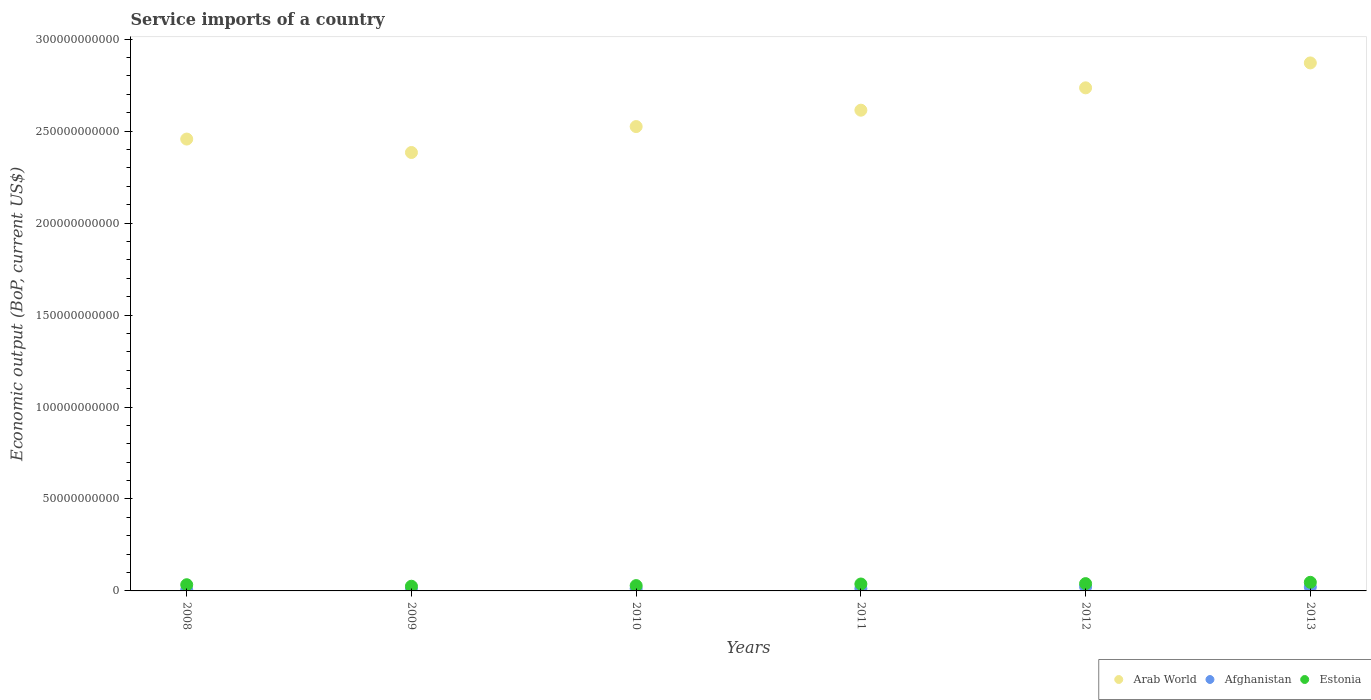How many different coloured dotlines are there?
Provide a short and direct response. 3. Is the number of dotlines equal to the number of legend labels?
Offer a terse response. Yes. What is the service imports in Afghanistan in 2010?
Make the answer very short. 1.26e+09. Across all years, what is the maximum service imports in Arab World?
Provide a short and direct response. 2.87e+11. Across all years, what is the minimum service imports in Afghanistan?
Make the answer very short. 5.71e+08. In which year was the service imports in Estonia minimum?
Ensure brevity in your answer.  2009. What is the total service imports in Estonia in the graph?
Offer a terse response. 2.12e+1. What is the difference between the service imports in Estonia in 2008 and that in 2009?
Your response must be concise. 8.25e+08. What is the difference between the service imports in Arab World in 2013 and the service imports in Estonia in 2009?
Provide a succinct answer. 2.85e+11. What is the average service imports in Afghanistan per year?
Provide a short and direct response. 1.39e+09. In the year 2010, what is the difference between the service imports in Arab World and service imports in Estonia?
Offer a terse response. 2.50e+11. In how many years, is the service imports in Arab World greater than 210000000000 US$?
Keep it short and to the point. 6. What is the ratio of the service imports in Estonia in 2008 to that in 2010?
Keep it short and to the point. 1.16. Is the service imports in Estonia in 2009 less than that in 2010?
Provide a short and direct response. Yes. What is the difference between the highest and the second highest service imports in Estonia?
Keep it short and to the point. 7.12e+08. What is the difference between the highest and the lowest service imports in Afghanistan?
Ensure brevity in your answer.  1.67e+09. In how many years, is the service imports in Estonia greater than the average service imports in Estonia taken over all years?
Your answer should be compact. 3. Is the sum of the service imports in Arab World in 2012 and 2013 greater than the maximum service imports in Estonia across all years?
Keep it short and to the point. Yes. Is it the case that in every year, the sum of the service imports in Arab World and service imports in Afghanistan  is greater than the service imports in Estonia?
Give a very brief answer. Yes. Does the service imports in Estonia monotonically increase over the years?
Make the answer very short. No. How many years are there in the graph?
Provide a short and direct response. 6. Does the graph contain any zero values?
Your answer should be compact. No. Does the graph contain grids?
Offer a terse response. No. What is the title of the graph?
Offer a terse response. Service imports of a country. What is the label or title of the Y-axis?
Offer a very short reply. Economic output (BoP, current US$). What is the Economic output (BoP, current US$) of Arab World in 2008?
Ensure brevity in your answer.  2.46e+11. What is the Economic output (BoP, current US$) in Afghanistan in 2008?
Your answer should be compact. 5.71e+08. What is the Economic output (BoP, current US$) in Estonia in 2008?
Your answer should be very brief. 3.37e+09. What is the Economic output (BoP, current US$) in Arab World in 2009?
Keep it short and to the point. 2.38e+11. What is the Economic output (BoP, current US$) in Afghanistan in 2009?
Give a very brief answer. 8.36e+08. What is the Economic output (BoP, current US$) of Estonia in 2009?
Provide a succinct answer. 2.54e+09. What is the Economic output (BoP, current US$) of Arab World in 2010?
Your answer should be very brief. 2.52e+11. What is the Economic output (BoP, current US$) in Afghanistan in 2010?
Keep it short and to the point. 1.26e+09. What is the Economic output (BoP, current US$) of Estonia in 2010?
Offer a terse response. 2.89e+09. What is the Economic output (BoP, current US$) in Arab World in 2011?
Offer a very short reply. 2.61e+11. What is the Economic output (BoP, current US$) in Afghanistan in 2011?
Keep it short and to the point. 1.29e+09. What is the Economic output (BoP, current US$) in Estonia in 2011?
Your response must be concise. 3.76e+09. What is the Economic output (BoP, current US$) of Arab World in 2012?
Your answer should be very brief. 2.74e+11. What is the Economic output (BoP, current US$) in Afghanistan in 2012?
Provide a short and direct response. 2.24e+09. What is the Economic output (BoP, current US$) in Estonia in 2012?
Provide a succinct answer. 3.96e+09. What is the Economic output (BoP, current US$) of Arab World in 2013?
Provide a succinct answer. 2.87e+11. What is the Economic output (BoP, current US$) of Afghanistan in 2013?
Provide a succinct answer. 2.11e+09. What is the Economic output (BoP, current US$) in Estonia in 2013?
Provide a succinct answer. 4.68e+09. Across all years, what is the maximum Economic output (BoP, current US$) of Arab World?
Keep it short and to the point. 2.87e+11. Across all years, what is the maximum Economic output (BoP, current US$) of Afghanistan?
Offer a very short reply. 2.24e+09. Across all years, what is the maximum Economic output (BoP, current US$) in Estonia?
Your response must be concise. 4.68e+09. Across all years, what is the minimum Economic output (BoP, current US$) of Arab World?
Keep it short and to the point. 2.38e+11. Across all years, what is the minimum Economic output (BoP, current US$) in Afghanistan?
Offer a very short reply. 5.71e+08. Across all years, what is the minimum Economic output (BoP, current US$) of Estonia?
Your answer should be compact. 2.54e+09. What is the total Economic output (BoP, current US$) in Arab World in the graph?
Ensure brevity in your answer.  1.56e+12. What is the total Economic output (BoP, current US$) in Afghanistan in the graph?
Your answer should be compact. 8.32e+09. What is the total Economic output (BoP, current US$) in Estonia in the graph?
Offer a terse response. 2.12e+1. What is the difference between the Economic output (BoP, current US$) of Arab World in 2008 and that in 2009?
Provide a short and direct response. 7.30e+09. What is the difference between the Economic output (BoP, current US$) of Afghanistan in 2008 and that in 2009?
Your response must be concise. -2.65e+08. What is the difference between the Economic output (BoP, current US$) in Estonia in 2008 and that in 2009?
Your response must be concise. 8.25e+08. What is the difference between the Economic output (BoP, current US$) in Arab World in 2008 and that in 2010?
Your answer should be very brief. -6.80e+09. What is the difference between the Economic output (BoP, current US$) in Afghanistan in 2008 and that in 2010?
Provide a short and direct response. -6.88e+08. What is the difference between the Economic output (BoP, current US$) in Estonia in 2008 and that in 2010?
Offer a very short reply. 4.76e+08. What is the difference between the Economic output (BoP, current US$) in Arab World in 2008 and that in 2011?
Offer a terse response. -1.57e+1. What is the difference between the Economic output (BoP, current US$) of Afghanistan in 2008 and that in 2011?
Your answer should be compact. -7.18e+08. What is the difference between the Economic output (BoP, current US$) in Estonia in 2008 and that in 2011?
Your answer should be compact. -3.96e+08. What is the difference between the Economic output (BoP, current US$) of Arab World in 2008 and that in 2012?
Make the answer very short. -2.79e+1. What is the difference between the Economic output (BoP, current US$) in Afghanistan in 2008 and that in 2012?
Your response must be concise. -1.67e+09. What is the difference between the Economic output (BoP, current US$) of Estonia in 2008 and that in 2012?
Provide a succinct answer. -5.98e+08. What is the difference between the Economic output (BoP, current US$) in Arab World in 2008 and that in 2013?
Make the answer very short. -4.14e+1. What is the difference between the Economic output (BoP, current US$) of Afghanistan in 2008 and that in 2013?
Give a very brief answer. -1.54e+09. What is the difference between the Economic output (BoP, current US$) of Estonia in 2008 and that in 2013?
Your answer should be very brief. -1.31e+09. What is the difference between the Economic output (BoP, current US$) in Arab World in 2009 and that in 2010?
Your answer should be very brief. -1.41e+1. What is the difference between the Economic output (BoP, current US$) of Afghanistan in 2009 and that in 2010?
Ensure brevity in your answer.  -4.23e+08. What is the difference between the Economic output (BoP, current US$) of Estonia in 2009 and that in 2010?
Give a very brief answer. -3.49e+08. What is the difference between the Economic output (BoP, current US$) in Arab World in 2009 and that in 2011?
Give a very brief answer. -2.30e+1. What is the difference between the Economic output (BoP, current US$) of Afghanistan in 2009 and that in 2011?
Your answer should be compact. -4.54e+08. What is the difference between the Economic output (BoP, current US$) of Estonia in 2009 and that in 2011?
Provide a succinct answer. -1.22e+09. What is the difference between the Economic output (BoP, current US$) in Arab World in 2009 and that in 2012?
Offer a terse response. -3.52e+1. What is the difference between the Economic output (BoP, current US$) in Afghanistan in 2009 and that in 2012?
Your answer should be compact. -1.41e+09. What is the difference between the Economic output (BoP, current US$) of Estonia in 2009 and that in 2012?
Your response must be concise. -1.42e+09. What is the difference between the Economic output (BoP, current US$) in Arab World in 2009 and that in 2013?
Keep it short and to the point. -4.87e+1. What is the difference between the Economic output (BoP, current US$) in Afghanistan in 2009 and that in 2013?
Your answer should be compact. -1.28e+09. What is the difference between the Economic output (BoP, current US$) of Estonia in 2009 and that in 2013?
Your response must be concise. -2.14e+09. What is the difference between the Economic output (BoP, current US$) of Arab World in 2010 and that in 2011?
Make the answer very short. -8.90e+09. What is the difference between the Economic output (BoP, current US$) in Afghanistan in 2010 and that in 2011?
Offer a terse response. -3.05e+07. What is the difference between the Economic output (BoP, current US$) of Estonia in 2010 and that in 2011?
Offer a terse response. -8.72e+08. What is the difference between the Economic output (BoP, current US$) of Arab World in 2010 and that in 2012?
Provide a short and direct response. -2.11e+1. What is the difference between the Economic output (BoP, current US$) in Afghanistan in 2010 and that in 2012?
Provide a succinct answer. -9.86e+08. What is the difference between the Economic output (BoP, current US$) of Estonia in 2010 and that in 2012?
Give a very brief answer. -1.07e+09. What is the difference between the Economic output (BoP, current US$) of Arab World in 2010 and that in 2013?
Offer a very short reply. -3.46e+1. What is the difference between the Economic output (BoP, current US$) of Afghanistan in 2010 and that in 2013?
Ensure brevity in your answer.  -8.56e+08. What is the difference between the Economic output (BoP, current US$) in Estonia in 2010 and that in 2013?
Provide a short and direct response. -1.79e+09. What is the difference between the Economic output (BoP, current US$) in Arab World in 2011 and that in 2012?
Keep it short and to the point. -1.22e+1. What is the difference between the Economic output (BoP, current US$) of Afghanistan in 2011 and that in 2012?
Offer a very short reply. -9.55e+08. What is the difference between the Economic output (BoP, current US$) in Estonia in 2011 and that in 2012?
Your response must be concise. -2.02e+08. What is the difference between the Economic output (BoP, current US$) of Arab World in 2011 and that in 2013?
Provide a short and direct response. -2.57e+1. What is the difference between the Economic output (BoP, current US$) of Afghanistan in 2011 and that in 2013?
Your response must be concise. -8.25e+08. What is the difference between the Economic output (BoP, current US$) in Estonia in 2011 and that in 2013?
Keep it short and to the point. -9.14e+08. What is the difference between the Economic output (BoP, current US$) in Arab World in 2012 and that in 2013?
Your answer should be compact. -1.35e+1. What is the difference between the Economic output (BoP, current US$) of Afghanistan in 2012 and that in 2013?
Provide a succinct answer. 1.30e+08. What is the difference between the Economic output (BoP, current US$) in Estonia in 2012 and that in 2013?
Keep it short and to the point. -7.12e+08. What is the difference between the Economic output (BoP, current US$) in Arab World in 2008 and the Economic output (BoP, current US$) in Afghanistan in 2009?
Your answer should be very brief. 2.45e+11. What is the difference between the Economic output (BoP, current US$) in Arab World in 2008 and the Economic output (BoP, current US$) in Estonia in 2009?
Offer a very short reply. 2.43e+11. What is the difference between the Economic output (BoP, current US$) in Afghanistan in 2008 and the Economic output (BoP, current US$) in Estonia in 2009?
Offer a terse response. -1.97e+09. What is the difference between the Economic output (BoP, current US$) in Arab World in 2008 and the Economic output (BoP, current US$) in Afghanistan in 2010?
Provide a short and direct response. 2.44e+11. What is the difference between the Economic output (BoP, current US$) in Arab World in 2008 and the Economic output (BoP, current US$) in Estonia in 2010?
Provide a succinct answer. 2.43e+11. What is the difference between the Economic output (BoP, current US$) in Afghanistan in 2008 and the Economic output (BoP, current US$) in Estonia in 2010?
Your answer should be compact. -2.32e+09. What is the difference between the Economic output (BoP, current US$) of Arab World in 2008 and the Economic output (BoP, current US$) of Afghanistan in 2011?
Ensure brevity in your answer.  2.44e+11. What is the difference between the Economic output (BoP, current US$) in Arab World in 2008 and the Economic output (BoP, current US$) in Estonia in 2011?
Ensure brevity in your answer.  2.42e+11. What is the difference between the Economic output (BoP, current US$) of Afghanistan in 2008 and the Economic output (BoP, current US$) of Estonia in 2011?
Ensure brevity in your answer.  -3.19e+09. What is the difference between the Economic output (BoP, current US$) of Arab World in 2008 and the Economic output (BoP, current US$) of Afghanistan in 2012?
Provide a succinct answer. 2.43e+11. What is the difference between the Economic output (BoP, current US$) of Arab World in 2008 and the Economic output (BoP, current US$) of Estonia in 2012?
Provide a succinct answer. 2.42e+11. What is the difference between the Economic output (BoP, current US$) in Afghanistan in 2008 and the Economic output (BoP, current US$) in Estonia in 2012?
Offer a very short reply. -3.39e+09. What is the difference between the Economic output (BoP, current US$) in Arab World in 2008 and the Economic output (BoP, current US$) in Afghanistan in 2013?
Offer a terse response. 2.44e+11. What is the difference between the Economic output (BoP, current US$) of Arab World in 2008 and the Economic output (BoP, current US$) of Estonia in 2013?
Offer a very short reply. 2.41e+11. What is the difference between the Economic output (BoP, current US$) in Afghanistan in 2008 and the Economic output (BoP, current US$) in Estonia in 2013?
Your answer should be very brief. -4.11e+09. What is the difference between the Economic output (BoP, current US$) of Arab World in 2009 and the Economic output (BoP, current US$) of Afghanistan in 2010?
Offer a very short reply. 2.37e+11. What is the difference between the Economic output (BoP, current US$) of Arab World in 2009 and the Economic output (BoP, current US$) of Estonia in 2010?
Offer a very short reply. 2.35e+11. What is the difference between the Economic output (BoP, current US$) of Afghanistan in 2009 and the Economic output (BoP, current US$) of Estonia in 2010?
Offer a very short reply. -2.05e+09. What is the difference between the Economic output (BoP, current US$) of Arab World in 2009 and the Economic output (BoP, current US$) of Afghanistan in 2011?
Offer a terse response. 2.37e+11. What is the difference between the Economic output (BoP, current US$) in Arab World in 2009 and the Economic output (BoP, current US$) in Estonia in 2011?
Your response must be concise. 2.35e+11. What is the difference between the Economic output (BoP, current US$) of Afghanistan in 2009 and the Economic output (BoP, current US$) of Estonia in 2011?
Provide a succinct answer. -2.93e+09. What is the difference between the Economic output (BoP, current US$) in Arab World in 2009 and the Economic output (BoP, current US$) in Afghanistan in 2012?
Your answer should be very brief. 2.36e+11. What is the difference between the Economic output (BoP, current US$) of Arab World in 2009 and the Economic output (BoP, current US$) of Estonia in 2012?
Provide a short and direct response. 2.34e+11. What is the difference between the Economic output (BoP, current US$) of Afghanistan in 2009 and the Economic output (BoP, current US$) of Estonia in 2012?
Keep it short and to the point. -3.13e+09. What is the difference between the Economic output (BoP, current US$) of Arab World in 2009 and the Economic output (BoP, current US$) of Afghanistan in 2013?
Offer a very short reply. 2.36e+11. What is the difference between the Economic output (BoP, current US$) of Arab World in 2009 and the Economic output (BoP, current US$) of Estonia in 2013?
Offer a very short reply. 2.34e+11. What is the difference between the Economic output (BoP, current US$) in Afghanistan in 2009 and the Economic output (BoP, current US$) in Estonia in 2013?
Ensure brevity in your answer.  -3.84e+09. What is the difference between the Economic output (BoP, current US$) in Arab World in 2010 and the Economic output (BoP, current US$) in Afghanistan in 2011?
Your response must be concise. 2.51e+11. What is the difference between the Economic output (BoP, current US$) in Arab World in 2010 and the Economic output (BoP, current US$) in Estonia in 2011?
Offer a very short reply. 2.49e+11. What is the difference between the Economic output (BoP, current US$) in Afghanistan in 2010 and the Economic output (BoP, current US$) in Estonia in 2011?
Provide a short and direct response. -2.50e+09. What is the difference between the Economic output (BoP, current US$) of Arab World in 2010 and the Economic output (BoP, current US$) of Afghanistan in 2012?
Give a very brief answer. 2.50e+11. What is the difference between the Economic output (BoP, current US$) in Arab World in 2010 and the Economic output (BoP, current US$) in Estonia in 2012?
Offer a terse response. 2.49e+11. What is the difference between the Economic output (BoP, current US$) of Afghanistan in 2010 and the Economic output (BoP, current US$) of Estonia in 2012?
Give a very brief answer. -2.71e+09. What is the difference between the Economic output (BoP, current US$) of Arab World in 2010 and the Economic output (BoP, current US$) of Afghanistan in 2013?
Your answer should be compact. 2.50e+11. What is the difference between the Economic output (BoP, current US$) of Arab World in 2010 and the Economic output (BoP, current US$) of Estonia in 2013?
Ensure brevity in your answer.  2.48e+11. What is the difference between the Economic output (BoP, current US$) of Afghanistan in 2010 and the Economic output (BoP, current US$) of Estonia in 2013?
Your answer should be very brief. -3.42e+09. What is the difference between the Economic output (BoP, current US$) of Arab World in 2011 and the Economic output (BoP, current US$) of Afghanistan in 2012?
Give a very brief answer. 2.59e+11. What is the difference between the Economic output (BoP, current US$) of Arab World in 2011 and the Economic output (BoP, current US$) of Estonia in 2012?
Provide a succinct answer. 2.57e+11. What is the difference between the Economic output (BoP, current US$) of Afghanistan in 2011 and the Economic output (BoP, current US$) of Estonia in 2012?
Your answer should be very brief. -2.68e+09. What is the difference between the Economic output (BoP, current US$) in Arab World in 2011 and the Economic output (BoP, current US$) in Afghanistan in 2013?
Ensure brevity in your answer.  2.59e+11. What is the difference between the Economic output (BoP, current US$) of Arab World in 2011 and the Economic output (BoP, current US$) of Estonia in 2013?
Offer a terse response. 2.57e+11. What is the difference between the Economic output (BoP, current US$) of Afghanistan in 2011 and the Economic output (BoP, current US$) of Estonia in 2013?
Your answer should be very brief. -3.39e+09. What is the difference between the Economic output (BoP, current US$) of Arab World in 2012 and the Economic output (BoP, current US$) of Afghanistan in 2013?
Offer a very short reply. 2.71e+11. What is the difference between the Economic output (BoP, current US$) of Arab World in 2012 and the Economic output (BoP, current US$) of Estonia in 2013?
Your answer should be compact. 2.69e+11. What is the difference between the Economic output (BoP, current US$) of Afghanistan in 2012 and the Economic output (BoP, current US$) of Estonia in 2013?
Your answer should be compact. -2.43e+09. What is the average Economic output (BoP, current US$) in Arab World per year?
Offer a very short reply. 2.60e+11. What is the average Economic output (BoP, current US$) of Afghanistan per year?
Your response must be concise. 1.39e+09. What is the average Economic output (BoP, current US$) in Estonia per year?
Your answer should be very brief. 3.53e+09. In the year 2008, what is the difference between the Economic output (BoP, current US$) of Arab World and Economic output (BoP, current US$) of Afghanistan?
Keep it short and to the point. 2.45e+11. In the year 2008, what is the difference between the Economic output (BoP, current US$) in Arab World and Economic output (BoP, current US$) in Estonia?
Give a very brief answer. 2.42e+11. In the year 2008, what is the difference between the Economic output (BoP, current US$) in Afghanistan and Economic output (BoP, current US$) in Estonia?
Your answer should be very brief. -2.80e+09. In the year 2009, what is the difference between the Economic output (BoP, current US$) in Arab World and Economic output (BoP, current US$) in Afghanistan?
Keep it short and to the point. 2.38e+11. In the year 2009, what is the difference between the Economic output (BoP, current US$) in Arab World and Economic output (BoP, current US$) in Estonia?
Give a very brief answer. 2.36e+11. In the year 2009, what is the difference between the Economic output (BoP, current US$) in Afghanistan and Economic output (BoP, current US$) in Estonia?
Ensure brevity in your answer.  -1.71e+09. In the year 2010, what is the difference between the Economic output (BoP, current US$) of Arab World and Economic output (BoP, current US$) of Afghanistan?
Ensure brevity in your answer.  2.51e+11. In the year 2010, what is the difference between the Economic output (BoP, current US$) in Arab World and Economic output (BoP, current US$) in Estonia?
Keep it short and to the point. 2.50e+11. In the year 2010, what is the difference between the Economic output (BoP, current US$) of Afghanistan and Economic output (BoP, current US$) of Estonia?
Keep it short and to the point. -1.63e+09. In the year 2011, what is the difference between the Economic output (BoP, current US$) of Arab World and Economic output (BoP, current US$) of Afghanistan?
Provide a succinct answer. 2.60e+11. In the year 2011, what is the difference between the Economic output (BoP, current US$) in Arab World and Economic output (BoP, current US$) in Estonia?
Provide a succinct answer. 2.58e+11. In the year 2011, what is the difference between the Economic output (BoP, current US$) in Afghanistan and Economic output (BoP, current US$) in Estonia?
Ensure brevity in your answer.  -2.47e+09. In the year 2012, what is the difference between the Economic output (BoP, current US$) in Arab World and Economic output (BoP, current US$) in Afghanistan?
Keep it short and to the point. 2.71e+11. In the year 2012, what is the difference between the Economic output (BoP, current US$) of Arab World and Economic output (BoP, current US$) of Estonia?
Your answer should be very brief. 2.70e+11. In the year 2012, what is the difference between the Economic output (BoP, current US$) in Afghanistan and Economic output (BoP, current US$) in Estonia?
Your response must be concise. -1.72e+09. In the year 2013, what is the difference between the Economic output (BoP, current US$) of Arab World and Economic output (BoP, current US$) of Afghanistan?
Provide a succinct answer. 2.85e+11. In the year 2013, what is the difference between the Economic output (BoP, current US$) in Arab World and Economic output (BoP, current US$) in Estonia?
Your answer should be very brief. 2.82e+11. In the year 2013, what is the difference between the Economic output (BoP, current US$) of Afghanistan and Economic output (BoP, current US$) of Estonia?
Provide a short and direct response. -2.56e+09. What is the ratio of the Economic output (BoP, current US$) of Arab World in 2008 to that in 2009?
Ensure brevity in your answer.  1.03. What is the ratio of the Economic output (BoP, current US$) in Afghanistan in 2008 to that in 2009?
Ensure brevity in your answer.  0.68. What is the ratio of the Economic output (BoP, current US$) in Estonia in 2008 to that in 2009?
Provide a succinct answer. 1.32. What is the ratio of the Economic output (BoP, current US$) in Arab World in 2008 to that in 2010?
Provide a succinct answer. 0.97. What is the ratio of the Economic output (BoP, current US$) in Afghanistan in 2008 to that in 2010?
Provide a short and direct response. 0.45. What is the ratio of the Economic output (BoP, current US$) of Estonia in 2008 to that in 2010?
Your response must be concise. 1.16. What is the ratio of the Economic output (BoP, current US$) of Arab World in 2008 to that in 2011?
Your response must be concise. 0.94. What is the ratio of the Economic output (BoP, current US$) in Afghanistan in 2008 to that in 2011?
Your answer should be very brief. 0.44. What is the ratio of the Economic output (BoP, current US$) in Estonia in 2008 to that in 2011?
Make the answer very short. 0.89. What is the ratio of the Economic output (BoP, current US$) in Arab World in 2008 to that in 2012?
Make the answer very short. 0.9. What is the ratio of the Economic output (BoP, current US$) in Afghanistan in 2008 to that in 2012?
Your answer should be compact. 0.25. What is the ratio of the Economic output (BoP, current US$) of Estonia in 2008 to that in 2012?
Make the answer very short. 0.85. What is the ratio of the Economic output (BoP, current US$) in Arab World in 2008 to that in 2013?
Keep it short and to the point. 0.86. What is the ratio of the Economic output (BoP, current US$) in Afghanistan in 2008 to that in 2013?
Keep it short and to the point. 0.27. What is the ratio of the Economic output (BoP, current US$) of Estonia in 2008 to that in 2013?
Ensure brevity in your answer.  0.72. What is the ratio of the Economic output (BoP, current US$) of Arab World in 2009 to that in 2010?
Give a very brief answer. 0.94. What is the ratio of the Economic output (BoP, current US$) in Afghanistan in 2009 to that in 2010?
Provide a short and direct response. 0.66. What is the ratio of the Economic output (BoP, current US$) in Estonia in 2009 to that in 2010?
Make the answer very short. 0.88. What is the ratio of the Economic output (BoP, current US$) in Arab World in 2009 to that in 2011?
Provide a succinct answer. 0.91. What is the ratio of the Economic output (BoP, current US$) in Afghanistan in 2009 to that in 2011?
Your answer should be very brief. 0.65. What is the ratio of the Economic output (BoP, current US$) of Estonia in 2009 to that in 2011?
Offer a very short reply. 0.68. What is the ratio of the Economic output (BoP, current US$) in Arab World in 2009 to that in 2012?
Offer a terse response. 0.87. What is the ratio of the Economic output (BoP, current US$) of Afghanistan in 2009 to that in 2012?
Your answer should be compact. 0.37. What is the ratio of the Economic output (BoP, current US$) of Estonia in 2009 to that in 2012?
Offer a terse response. 0.64. What is the ratio of the Economic output (BoP, current US$) in Arab World in 2009 to that in 2013?
Provide a succinct answer. 0.83. What is the ratio of the Economic output (BoP, current US$) of Afghanistan in 2009 to that in 2013?
Offer a very short reply. 0.4. What is the ratio of the Economic output (BoP, current US$) of Estonia in 2009 to that in 2013?
Make the answer very short. 0.54. What is the ratio of the Economic output (BoP, current US$) of Arab World in 2010 to that in 2011?
Provide a short and direct response. 0.97. What is the ratio of the Economic output (BoP, current US$) of Afghanistan in 2010 to that in 2011?
Provide a succinct answer. 0.98. What is the ratio of the Economic output (BoP, current US$) of Estonia in 2010 to that in 2011?
Your response must be concise. 0.77. What is the ratio of the Economic output (BoP, current US$) in Arab World in 2010 to that in 2012?
Offer a very short reply. 0.92. What is the ratio of the Economic output (BoP, current US$) in Afghanistan in 2010 to that in 2012?
Your answer should be compact. 0.56. What is the ratio of the Economic output (BoP, current US$) of Estonia in 2010 to that in 2012?
Your answer should be compact. 0.73. What is the ratio of the Economic output (BoP, current US$) in Arab World in 2010 to that in 2013?
Keep it short and to the point. 0.88. What is the ratio of the Economic output (BoP, current US$) of Afghanistan in 2010 to that in 2013?
Give a very brief answer. 0.6. What is the ratio of the Economic output (BoP, current US$) of Estonia in 2010 to that in 2013?
Your answer should be very brief. 0.62. What is the ratio of the Economic output (BoP, current US$) of Arab World in 2011 to that in 2012?
Make the answer very short. 0.96. What is the ratio of the Economic output (BoP, current US$) in Afghanistan in 2011 to that in 2012?
Your response must be concise. 0.57. What is the ratio of the Economic output (BoP, current US$) of Estonia in 2011 to that in 2012?
Keep it short and to the point. 0.95. What is the ratio of the Economic output (BoP, current US$) of Arab World in 2011 to that in 2013?
Ensure brevity in your answer.  0.91. What is the ratio of the Economic output (BoP, current US$) of Afghanistan in 2011 to that in 2013?
Provide a succinct answer. 0.61. What is the ratio of the Economic output (BoP, current US$) in Estonia in 2011 to that in 2013?
Give a very brief answer. 0.8. What is the ratio of the Economic output (BoP, current US$) of Arab World in 2012 to that in 2013?
Provide a succinct answer. 0.95. What is the ratio of the Economic output (BoP, current US$) in Afghanistan in 2012 to that in 2013?
Your answer should be very brief. 1.06. What is the ratio of the Economic output (BoP, current US$) of Estonia in 2012 to that in 2013?
Provide a succinct answer. 0.85. What is the difference between the highest and the second highest Economic output (BoP, current US$) in Arab World?
Keep it short and to the point. 1.35e+1. What is the difference between the highest and the second highest Economic output (BoP, current US$) in Afghanistan?
Provide a short and direct response. 1.30e+08. What is the difference between the highest and the second highest Economic output (BoP, current US$) in Estonia?
Provide a short and direct response. 7.12e+08. What is the difference between the highest and the lowest Economic output (BoP, current US$) of Arab World?
Your answer should be compact. 4.87e+1. What is the difference between the highest and the lowest Economic output (BoP, current US$) of Afghanistan?
Give a very brief answer. 1.67e+09. What is the difference between the highest and the lowest Economic output (BoP, current US$) in Estonia?
Your response must be concise. 2.14e+09. 